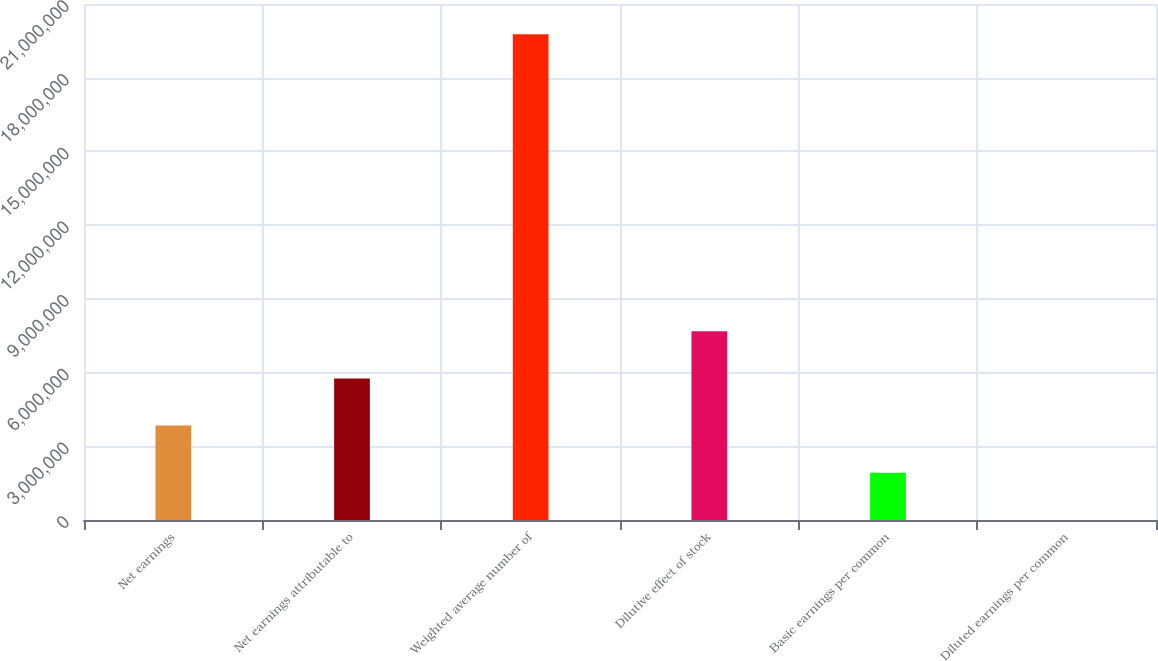Convert chart. <chart><loc_0><loc_0><loc_500><loc_500><bar_chart><fcel>Net earnings<fcel>Net earnings attributable to<fcel>Weighted average number of<fcel>Dilutive effect of stock<fcel>Basic earnings per common<fcel>Diluted earnings per common<nl><fcel>3.84222e+06<fcel>5.76332e+06<fcel>1.97733e+07<fcel>7.68443e+06<fcel>1.92111e+06<fcel>1.73<nl></chart> 